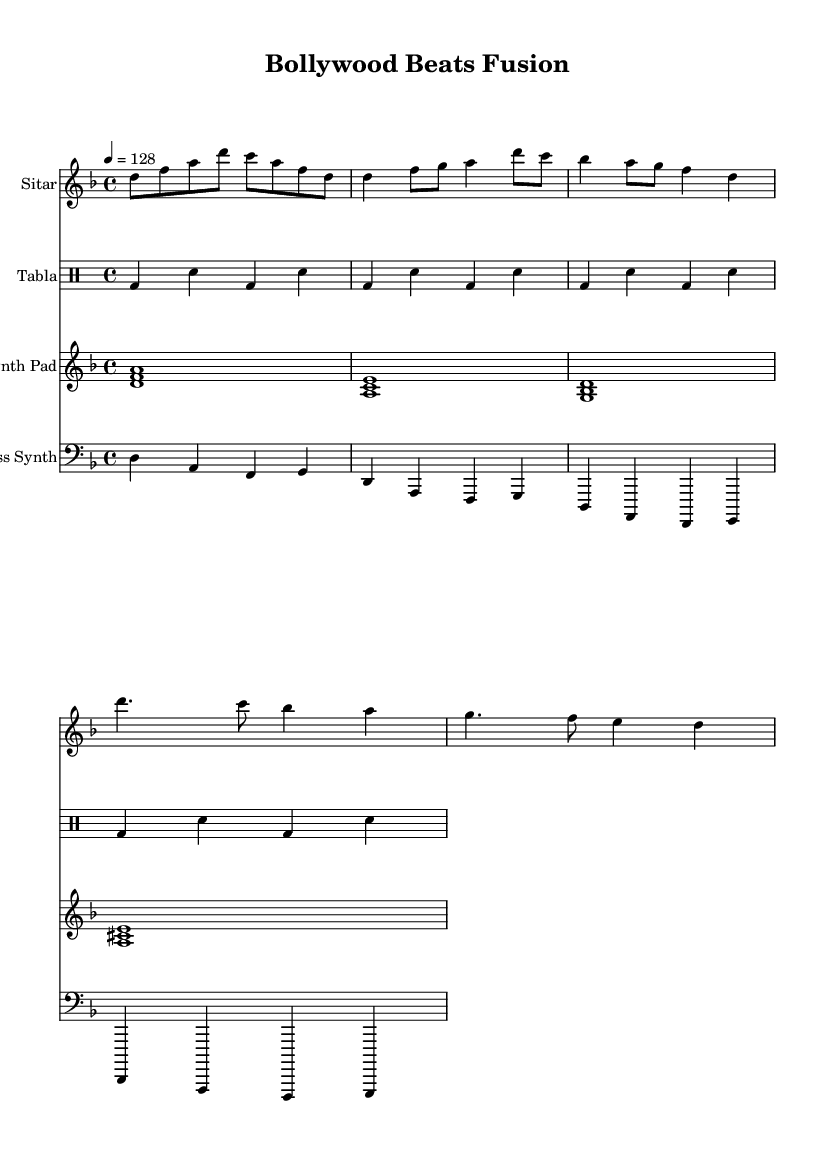What is the key signature of this music? The sheet music indicates a key signature of D minor, which is identified by the presence of one flat (B flat).
Answer: D minor What is the time signature of this music? The time signature is found at the beginning of the sheet music and is denoted as 4/4, indicating four beats per measure.
Answer: 4/4 What is the tempo marking in this music? The tempo marking at the beginning states that the piece should be played at a speed of 128 beats per minute.
Answer: 128 How many instruments are featured in the score? By counting the different staff sections in the score, we see Sitar, Tabla, Synth Pad, and Bass Synth, totaling four instruments.
Answer: Four What type of percussion is used in this composition? The percussion part is exclusively played on the Tabla, which is a traditional Indian percussion instrument known for its distinctive rhythmic patterns.
Answer: Tabla Explain the progression of the bass synth in the first line. The bass synth follows a repetitive four-bar pattern that alternates the notes D, A, F, and G, contributing a foundational harmonic structure to the piece.
Answer: D, A, F, G What fusion genre does this music represent? The combination of classical Indian instruments, like the Sitar and Tabla, with electronic elements like Synth Pad and Bass Synth defines this piece as East-meets-West fusion.
Answer: East-meets-West fusion 